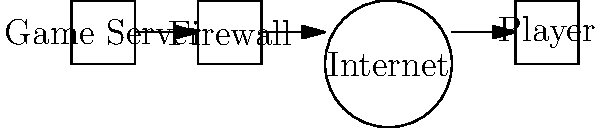As an indie game developer, you're setting up a game server with a firewall. Given the network topology shown, which firewall rule would you implement to allow players to connect to your game server while maintaining security and preventing potential DDoS attacks? To answer this question, let's consider the following steps:

1. Identify the game server's needs:
   - Allow incoming connections from players
   - Protect against potential DDoS attacks

2. Understand the basic firewall principles:
   - Firewalls control traffic based on rules
   - Rules can filter by IP, port, and protocol

3. Consider the indie game developer perspective:
   - Limited resources for complex security setups
   - Need for a balance between accessibility and security

4. Analyze the network topology:
   - Game server is behind a firewall
   - Players connect through the internet

5. Determine the best firewall rule:
   - Allow incoming connections only on the specific game port
   - Limit the rate of new connections to mitigate DDoS attacks

6. Implement the rule:
   - Open the game's port (e.g., UDP port 27015 for many games)
   - Set a connection rate limit (e.g., 60 new connections per minute)

The optimal firewall rule would be to allow incoming UDP traffic on port 27015 (or your game's specific port) with a rate limit of 60 new connections per minute. This allows players to connect while providing basic DDoS protection.
Answer: Allow UDP:27015, rate limit 60 conn/min 